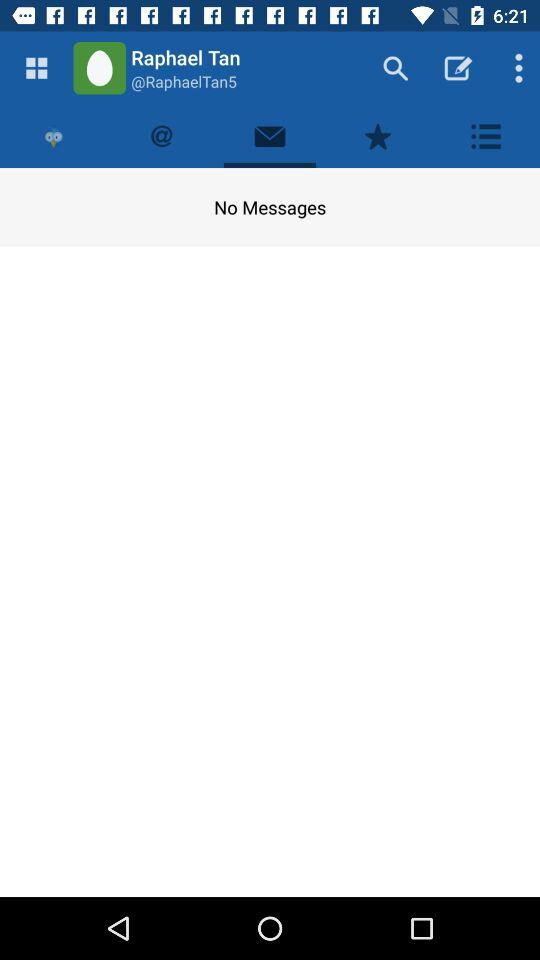Which tab has been selected? The tab that has been selected is "Messages". 